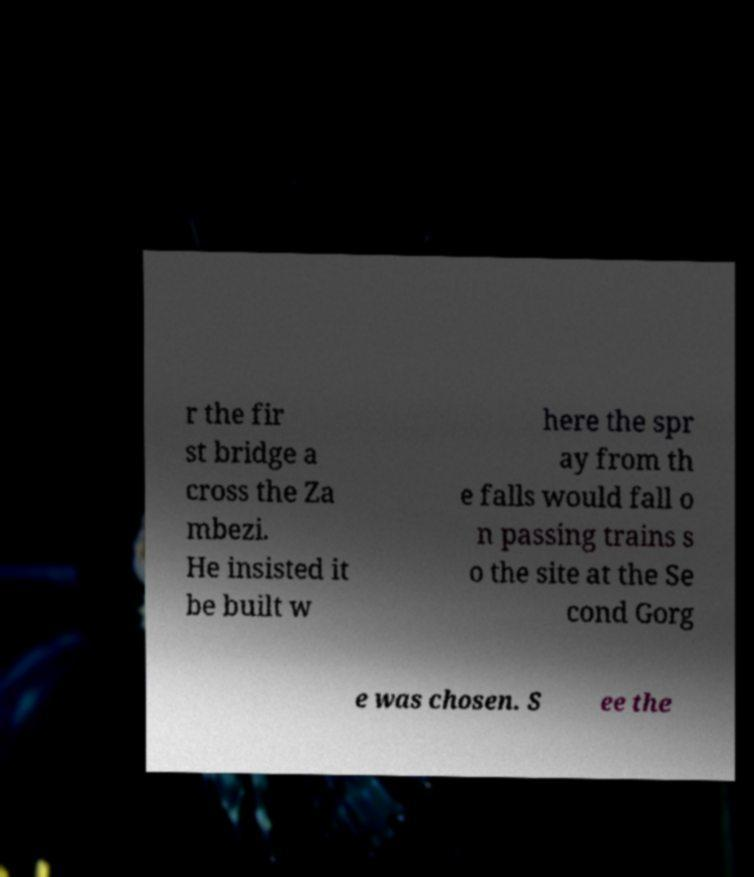Please identify and transcribe the text found in this image. r the fir st bridge a cross the Za mbezi. He insisted it be built w here the spr ay from th e falls would fall o n passing trains s o the site at the Se cond Gorg e was chosen. S ee the 